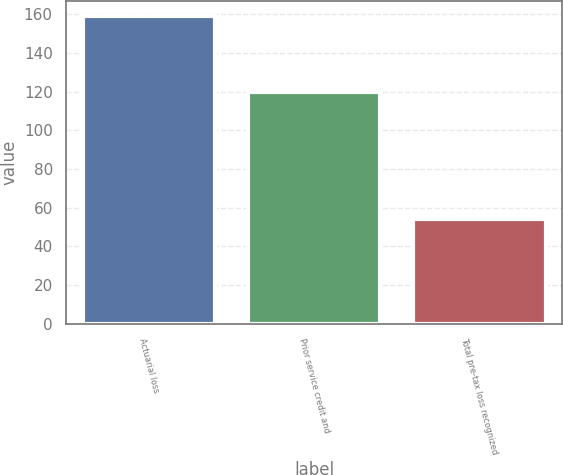Convert chart. <chart><loc_0><loc_0><loc_500><loc_500><bar_chart><fcel>Actuarial loss<fcel>Prior service credit and<fcel>Total pre-tax loss recognized<nl><fcel>159<fcel>120<fcel>54<nl></chart> 